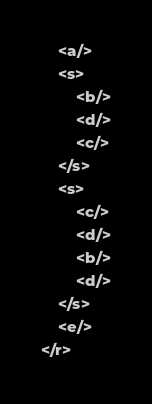Convert code to text. <code><loc_0><loc_0><loc_500><loc_500><_XML_>	<a/>
	<s>
		<b/>
		<d/>
		<c/>
	</s>
	<s>
		<c/>
		<d/>
		<b/>
		<d/>
	</s>
	<e/>
</r></code> 